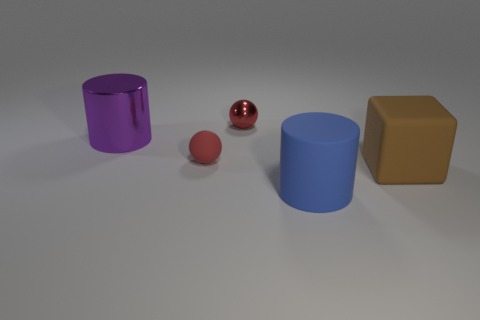Add 2 small metallic spheres. How many objects exist? 7 Subtract all spheres. How many objects are left? 3 Add 1 large cylinders. How many large cylinders are left? 3 Add 2 cyan matte blocks. How many cyan matte blocks exist? 2 Subtract 0 yellow spheres. How many objects are left? 5 Subtract all yellow metallic balls. Subtract all blue objects. How many objects are left? 4 